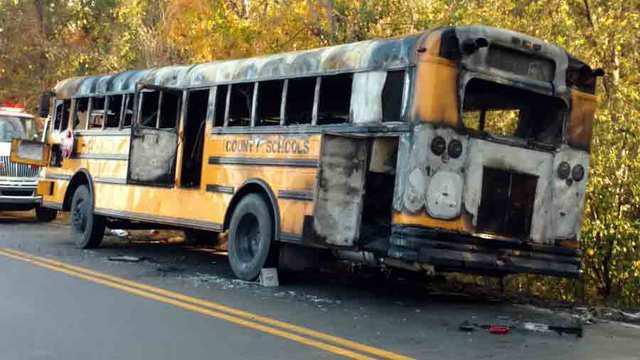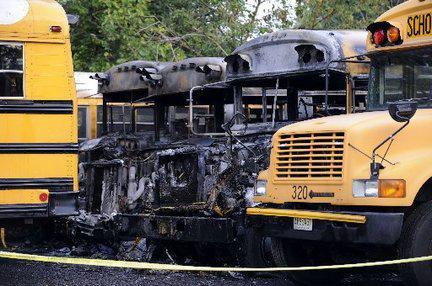The first image is the image on the left, the second image is the image on the right. Given the left and right images, does the statement "At least one of the schoolbusses is on fire." hold true? Answer yes or no. No. The first image is the image on the left, the second image is the image on the right. Analyze the images presented: Is the assertion "In at least one image, a fire is blazing at the front of a bus parked with its red stop sign facing the camera." valid? Answer yes or no. No. 